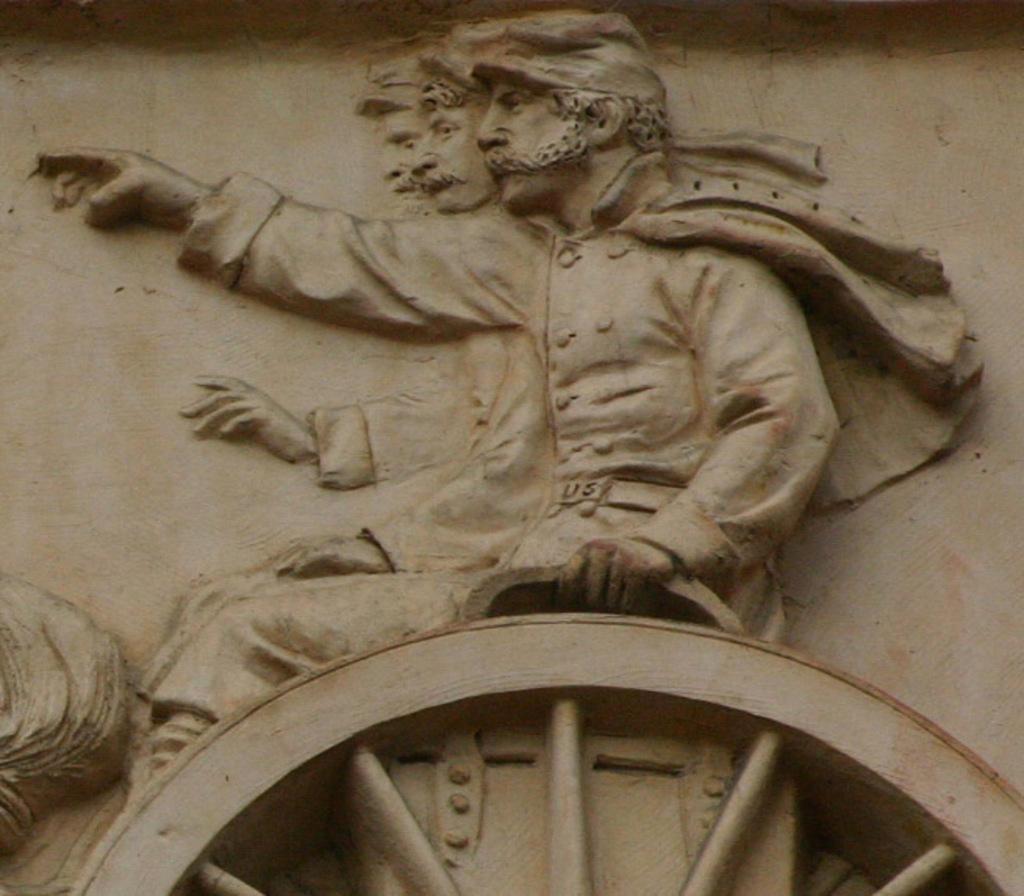Could you give a brief overview of what you see in this image? We can see stone carving of people and wheel on a wall. 